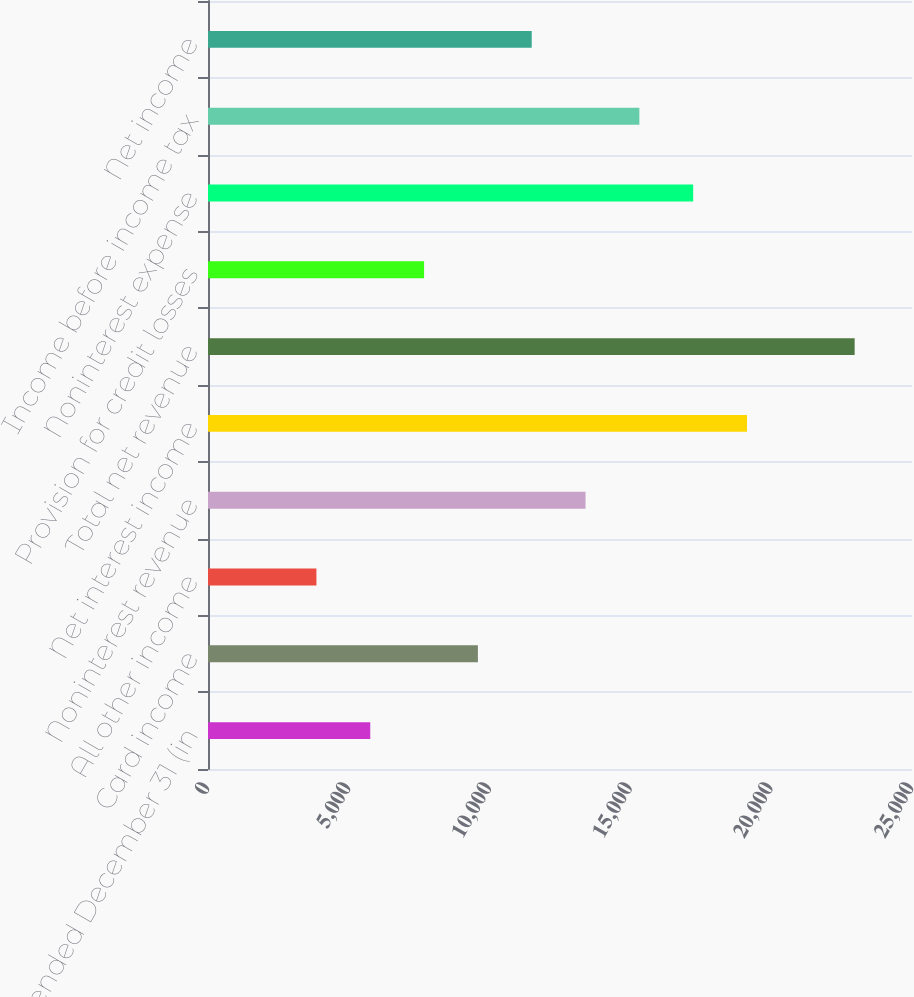Convert chart to OTSL. <chart><loc_0><loc_0><loc_500><loc_500><bar_chart><fcel>Year ended December 31 (in<fcel>Card income<fcel>All other income<fcel>Noninterest revenue<fcel>Net interest income<fcel>Total net revenue<fcel>Provision for credit losses<fcel>Noninterest expense<fcel>Income before income tax<fcel>Net income<nl><fcel>5761.9<fcel>9584.5<fcel>3850.6<fcel>13407.1<fcel>19141<fcel>22963.6<fcel>7673.2<fcel>17229.7<fcel>15318.4<fcel>11495.8<nl></chart> 